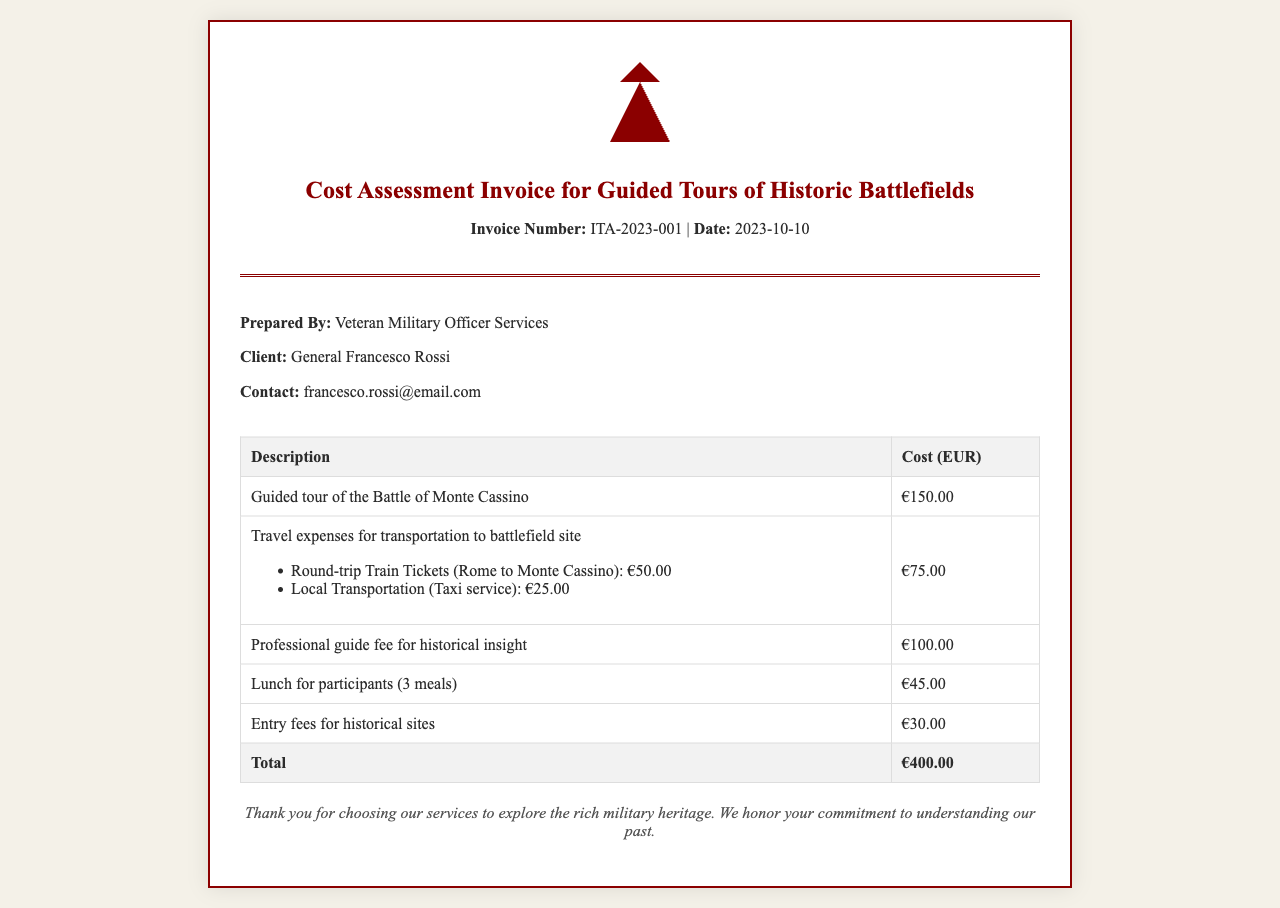What is the total cost of the guided tour? The total cost is clearly stated in the invoice as the final amount, which includes all services provided.
Answer: €400.00 Who is the client of the invoice? The document identifies the individual receiving the services and mentions their name explicitly under the client section.
Answer: General Francesco Rossi What date was the invoice issued? The date on the invoice is provided prominently and is associated with the invoice header for easy reference.
Answer: 2023-10-10 What is the cost of the guided tour of the Battle of Monte Cassino? The specific cost for the guided tour is listed in the table of services with the respective price.
Answer: €150.00 What are the travel expenses listed in the invoice? The invoice details the components of travel expenses, which include tickets and local transportation, all of which must be summed up for clarity.
Answer: €75.00 What is the fee for the professional guide? The document specifies the charge for the guide's expertise, which is distinctly mentioned in the cost breakdown.
Answer: €100.00 How many meals are included in the lunch expense? The invoice describes the cost related to meals and specifies the number of meals covered, which shows what the charge encompasses.
Answer: 3 meals What type of services does this invoice represent? The overall purpose of the invoice is directly associated with the guided experiences related to history, which can be derived from the title and content of the document.
Answer: Guided Tours 